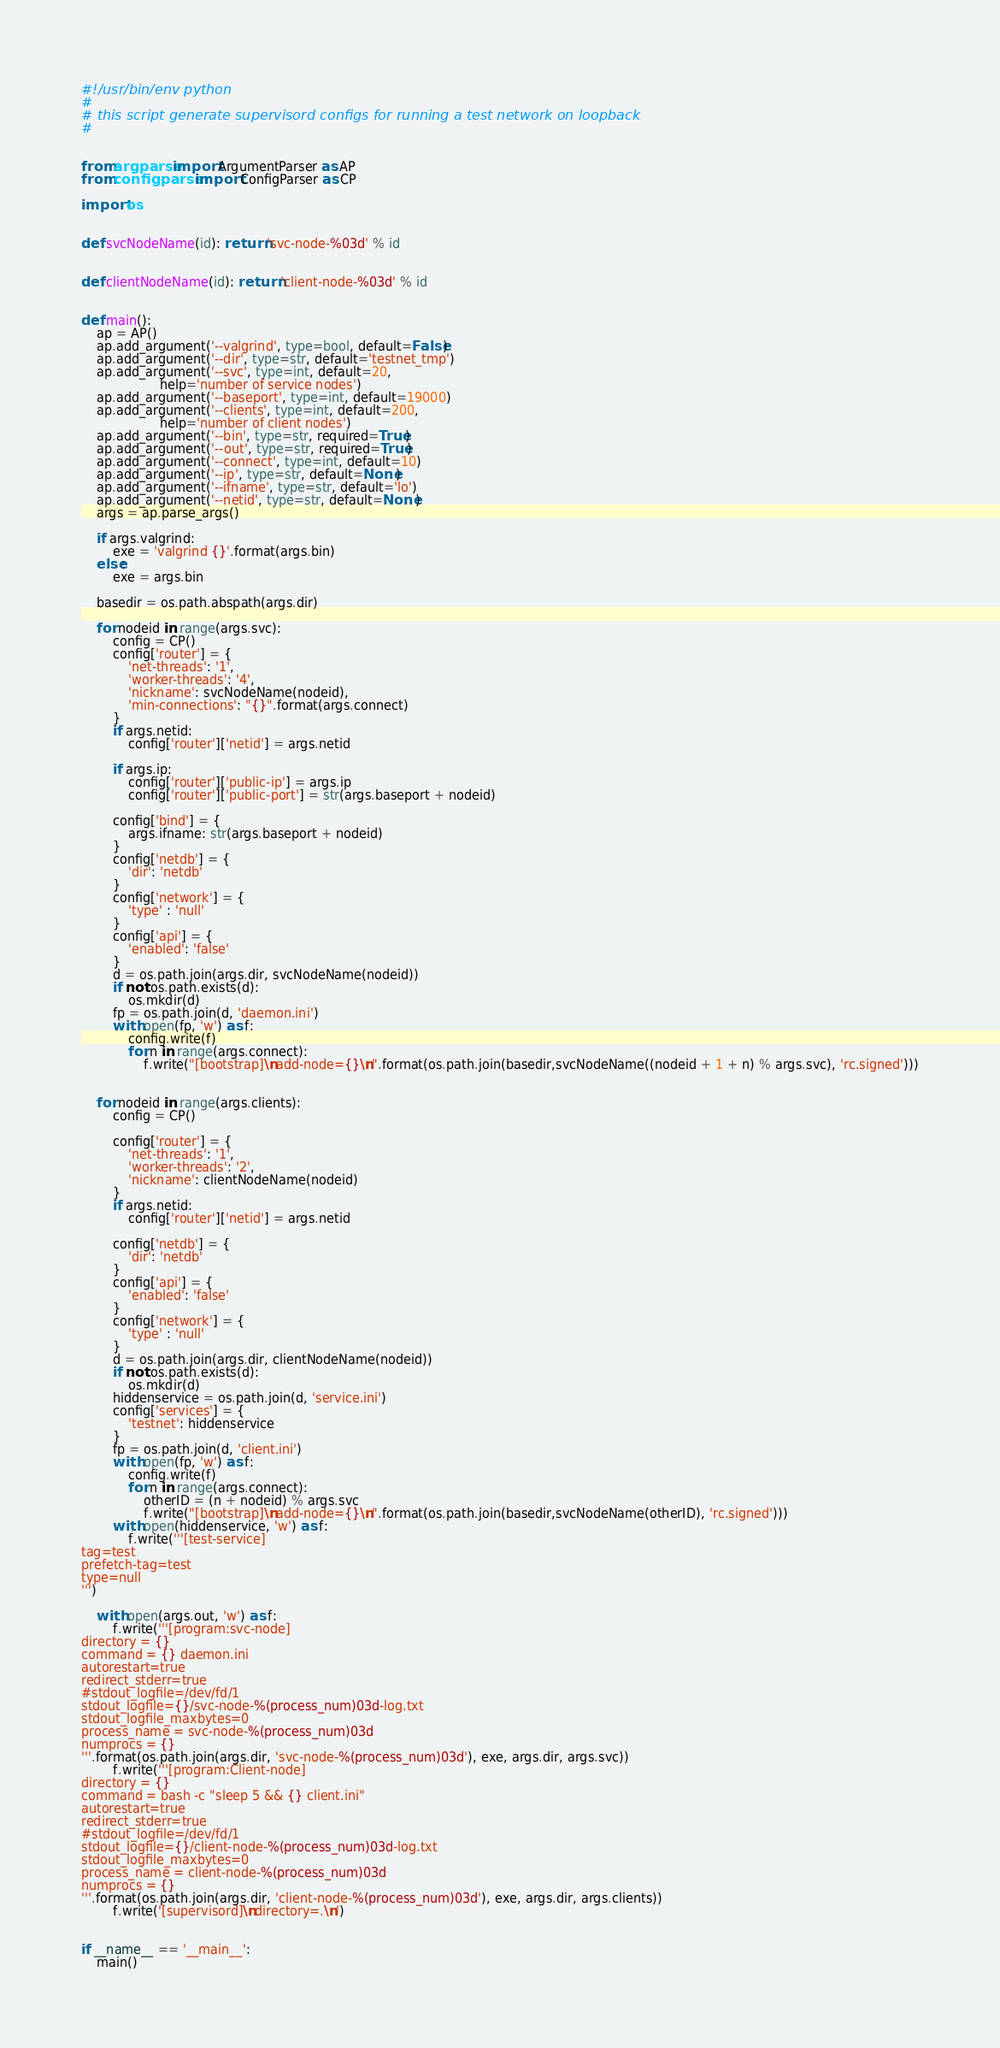<code> <loc_0><loc_0><loc_500><loc_500><_Python_>#!/usr/bin/env python
#
# this script generate supervisord configs for running a test network on loopback
#


from argparse import ArgumentParser as AP
from configparser import ConfigParser as CP

import os


def svcNodeName(id): return 'svc-node-%03d' % id


def clientNodeName(id): return 'client-node-%03d' % id


def main():
    ap = AP()
    ap.add_argument('--valgrind', type=bool, default=False)
    ap.add_argument('--dir', type=str, default='testnet_tmp')
    ap.add_argument('--svc', type=int, default=20,
                    help='number of service nodes')
    ap.add_argument('--baseport', type=int, default=19000)
    ap.add_argument('--clients', type=int, default=200,
                    help='number of client nodes')
    ap.add_argument('--bin', type=str, required=True)
    ap.add_argument('--out', type=str, required=True)
    ap.add_argument('--connect', type=int, default=10)
    ap.add_argument('--ip', type=str, default=None)
    ap.add_argument('--ifname', type=str, default='lo')
    ap.add_argument('--netid', type=str, default=None)
    args = ap.parse_args()

    if args.valgrind:
        exe = 'valgrind {}'.format(args.bin)
    else:
        exe = args.bin
        
    basedir = os.path.abspath(args.dir)

    for nodeid in range(args.svc):
        config = CP()
        config['router'] = {
            'net-threads': '1',
            'worker-threads': '4',
            'nickname': svcNodeName(nodeid),
            'min-connections': "{}".format(args.connect)
        }
        if args.netid:
            config['router']['netid'] = args.netid
            
        if args.ip:
            config['router']['public-ip'] = args.ip
            config['router']['public-port'] = str(args.baseport + nodeid)
            
        config['bind'] = {
            args.ifname: str(args.baseport + nodeid)
        }
        config['netdb'] = {
            'dir': 'netdb'
        }
        config['network'] = {
            'type' : 'null'
        }
        config['api'] = {
            'enabled': 'false'
        }
        d = os.path.join(args.dir, svcNodeName(nodeid))
        if not os.path.exists(d):
            os.mkdir(d)
        fp = os.path.join(d, 'daemon.ini')
        with open(fp, 'w') as f:
            config.write(f)
            for n in range(args.connect):
                f.write("[bootstrap]\nadd-node={}\n".format(os.path.join(basedir,svcNodeName((nodeid + 1 + n) % args.svc), 'rc.signed')))

        
    for nodeid in range(args.clients):
        config = CP()

        config['router'] = {
            'net-threads': '1',
            'worker-threads': '2',
            'nickname': clientNodeName(nodeid)
        }
        if args.netid:
            config['router']['netid'] = args.netid

        config['netdb'] = {
            'dir': 'netdb'
        }
        config['api'] = {
            'enabled': 'false'
        }
        config['network'] = {
            'type' : 'null'
        }
        d = os.path.join(args.dir, clientNodeName(nodeid))
        if not os.path.exists(d):
            os.mkdir(d)
        hiddenservice = os.path.join(d, 'service.ini')
        config['services'] = {
            'testnet': hiddenservice
        }
        fp = os.path.join(d, 'client.ini')
        with open(fp, 'w') as f:
            config.write(f)
            for n in range(args.connect):
                otherID = (n + nodeid) % args.svc
                f.write("[bootstrap]\nadd-node={}\n".format(os.path.join(basedir,svcNodeName(otherID), 'rc.signed')))
        with open(hiddenservice, 'w') as f:
            f.write('''[test-service]
tag=test
prefetch-tag=test
type=null
''')

    with open(args.out, 'w') as f:
        f.write('''[program:svc-node]
directory = {}
command = {} daemon.ini
autorestart=true
redirect_stderr=true
#stdout_logfile=/dev/fd/1
stdout_logfile={}/svc-node-%(process_num)03d-log.txt
stdout_logfile_maxbytes=0
process_name = svc-node-%(process_num)03d
numprocs = {}
'''.format(os.path.join(args.dir, 'svc-node-%(process_num)03d'), exe, args.dir, args.svc))
        f.write('''[program:Client-node]
directory = {}
command = bash -c "sleep 5 && {} client.ini"
autorestart=true
redirect_stderr=true
#stdout_logfile=/dev/fd/1
stdout_logfile={}/client-node-%(process_num)03d-log.txt
stdout_logfile_maxbytes=0
process_name = client-node-%(process_num)03d
numprocs = {}
'''.format(os.path.join(args.dir, 'client-node-%(process_num)03d'), exe, args.dir, args.clients))
        f.write('[supervisord]\ndirectory=.\n')


if __name__ == '__main__':
    main()
</code> 